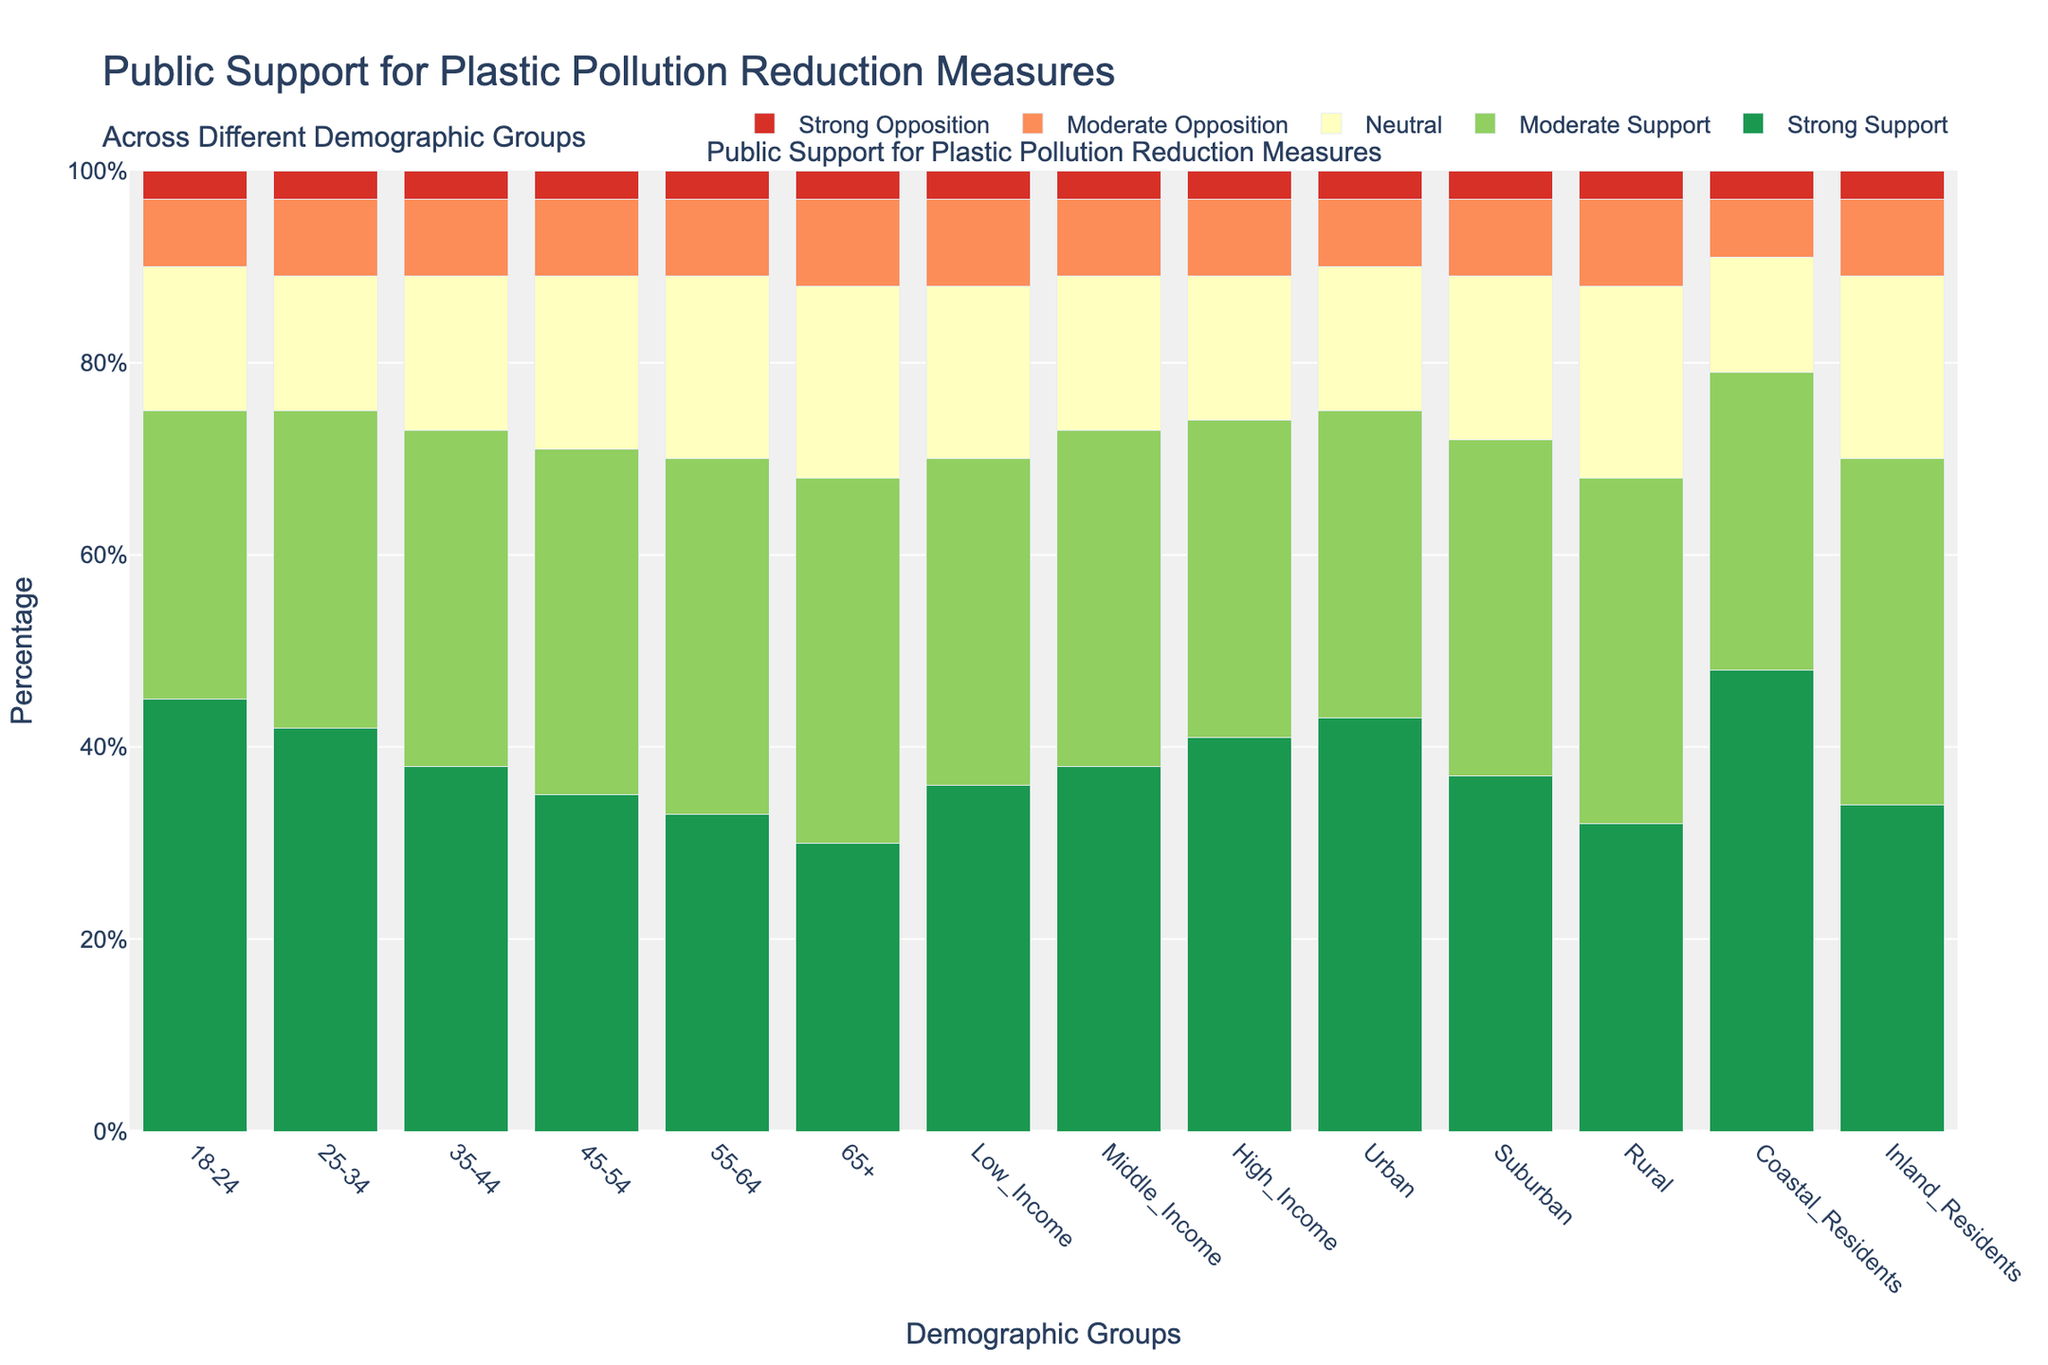What's the most supported plastic pollution reduction measure among coastal residents? Coastal residents display the highest strong support compared to other categories. By observing the highest green bar in the figure for Coastal Residents, it's clear that strong support is the leading measure.
Answer: Strong Support Which age group has the highest combined moderate and strong opposition? To determine this, we need to look at the height of the red and orange bars for each age group and add their values. The sum is highest in the group 65+ (9 + 3 = 12).
Answer: 65+ What is the average percentage of strong support across all age groups? To find the average strong support across age groups, sum the values of strong support (45 + 42 + 38 + 35 + 33 + 30) which equals 223, then divide by the number of age groups (6). So, 223 / 6 ≈ 37.17.
Answer: 37.17% How does support for plastic pollution reduction measures differ between coastal and inland residents? Coastal residents have the highest strong support (48%) and the lowest moderate opposition (6%) compared to inland residents who show lower strong support (34%) and higher moderate opposition (8%).
Answer: Coastal residents show higher strong support and lower moderate opposition compared to inland residents Which income group shows the least neutral stance towards plastic pollution reduction measures? By observing the yellow bars for each income group, the high-income group's bar is the shortest, indicating the lowest neutral percentage (15%).
Answer: High-Income How does the support for plastic pollution reduction measures in urban areas compare to rural areas? Urban areas have higher strong support (43%) and moderate support (32%) compared to rural areas which have lower strong support (32%) and moderate support (36%). Additionally, rural areas show a higher percentage of neutral stance (20%).
Answer: Urban areas have higher strong support and lower neutral stance compared to rural areas What percentage of the 25-34 age group shows opposition to plastic pollution reduction measures? Add the percentages of moderate opposition and strong opposition in the 25-34 age group (8% + 3% = 11%).
Answer: 11% Across all demographic groups, which one shows the highest percentage of strong support? Coastal Residents have the highest percentage of strong support, as seen by the tallest green bar which is 48%.
Answer: Coastal Residents Compare the moderate support percentages between the 18-24 and 55-64 age groups. The 18-24 age group has a moderate support percentage of 30%, while the 55-64 age group has a moderate support percentage of 37%.
Answer: 55-64 age group has higher moderate support 